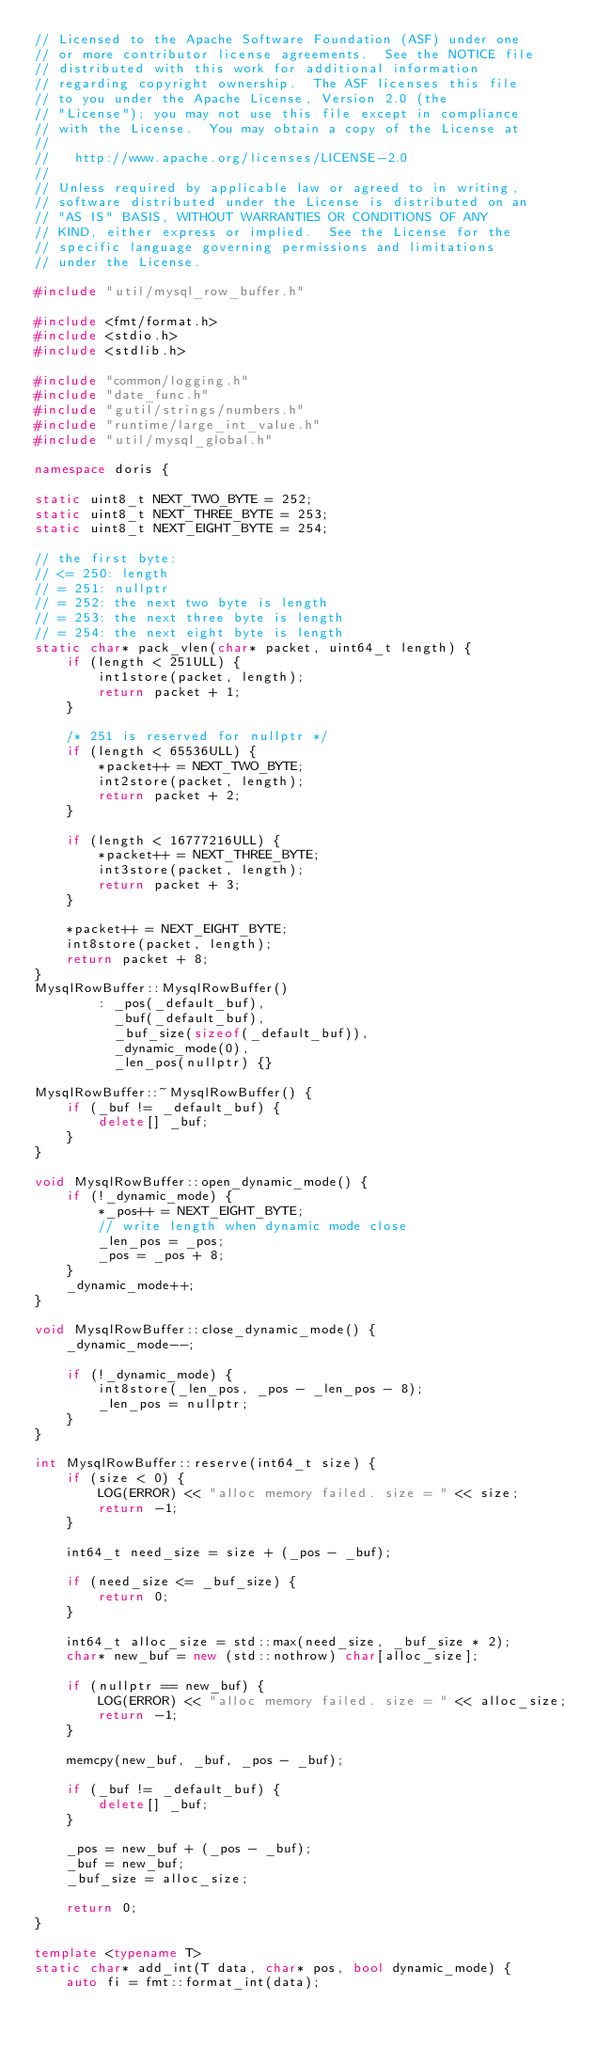Convert code to text. <code><loc_0><loc_0><loc_500><loc_500><_C++_>// Licensed to the Apache Software Foundation (ASF) under one
// or more contributor license agreements.  See the NOTICE file
// distributed with this work for additional information
// regarding copyright ownership.  The ASF licenses this file
// to you under the Apache License, Version 2.0 (the
// "License"); you may not use this file except in compliance
// with the License.  You may obtain a copy of the License at
//
//   http://www.apache.org/licenses/LICENSE-2.0
//
// Unless required by applicable law or agreed to in writing,
// software distributed under the License is distributed on an
// "AS IS" BASIS, WITHOUT WARRANTIES OR CONDITIONS OF ANY
// KIND, either express or implied.  See the License for the
// specific language governing permissions and limitations
// under the License.

#include "util/mysql_row_buffer.h"

#include <fmt/format.h>
#include <stdio.h>
#include <stdlib.h>

#include "common/logging.h"
#include "date_func.h"
#include "gutil/strings/numbers.h"
#include "runtime/large_int_value.h"
#include "util/mysql_global.h"

namespace doris {

static uint8_t NEXT_TWO_BYTE = 252;
static uint8_t NEXT_THREE_BYTE = 253;
static uint8_t NEXT_EIGHT_BYTE = 254;

// the first byte:
// <= 250: length
// = 251: nullptr
// = 252: the next two byte is length
// = 253: the next three byte is length
// = 254: the next eight byte is length
static char* pack_vlen(char* packet, uint64_t length) {
    if (length < 251ULL) {
        int1store(packet, length);
        return packet + 1;
    }

    /* 251 is reserved for nullptr */
    if (length < 65536ULL) {
        *packet++ = NEXT_TWO_BYTE;
        int2store(packet, length);
        return packet + 2;
    }

    if (length < 16777216ULL) {
        *packet++ = NEXT_THREE_BYTE;
        int3store(packet, length);
        return packet + 3;
    }

    *packet++ = NEXT_EIGHT_BYTE;
    int8store(packet, length);
    return packet + 8;
}
MysqlRowBuffer::MysqlRowBuffer()
        : _pos(_default_buf),
          _buf(_default_buf),
          _buf_size(sizeof(_default_buf)),
          _dynamic_mode(0),
          _len_pos(nullptr) {}

MysqlRowBuffer::~MysqlRowBuffer() {
    if (_buf != _default_buf) {
        delete[] _buf;
    }
}

void MysqlRowBuffer::open_dynamic_mode() {
    if (!_dynamic_mode) {
        *_pos++ = NEXT_EIGHT_BYTE;
        // write length when dynamic mode close
        _len_pos = _pos;
        _pos = _pos + 8;
    }
    _dynamic_mode++;
}

void MysqlRowBuffer::close_dynamic_mode() {
    _dynamic_mode--;

    if (!_dynamic_mode) {
        int8store(_len_pos, _pos - _len_pos - 8);
        _len_pos = nullptr;
    }
}

int MysqlRowBuffer::reserve(int64_t size) {
    if (size < 0) {
        LOG(ERROR) << "alloc memory failed. size = " << size;
        return -1;
    }

    int64_t need_size = size + (_pos - _buf);

    if (need_size <= _buf_size) {
        return 0;
    }

    int64_t alloc_size = std::max(need_size, _buf_size * 2);
    char* new_buf = new (std::nothrow) char[alloc_size];

    if (nullptr == new_buf) {
        LOG(ERROR) << "alloc memory failed. size = " << alloc_size;
        return -1;
    }

    memcpy(new_buf, _buf, _pos - _buf);

    if (_buf != _default_buf) {
        delete[] _buf;
    }

    _pos = new_buf + (_pos - _buf);
    _buf = new_buf;
    _buf_size = alloc_size;

    return 0;
}

template <typename T>
static char* add_int(T data, char* pos, bool dynamic_mode) {
    auto fi = fmt::format_int(data);</code> 